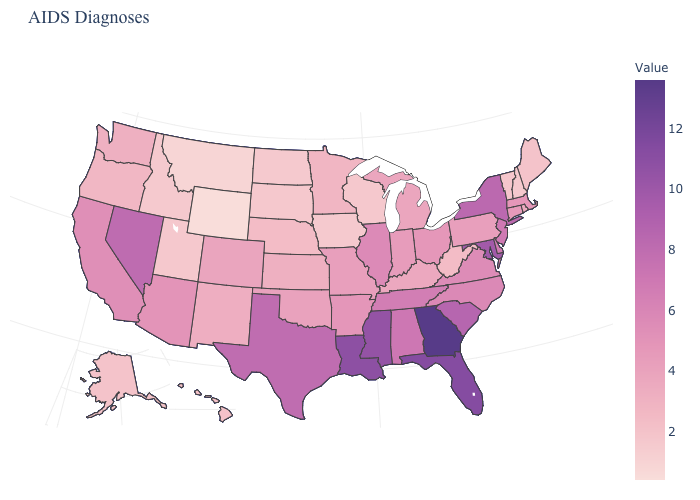Does West Virginia have the lowest value in the South?
Quick response, please. Yes. Among the states that border Oregon , does Washington have the lowest value?
Give a very brief answer. No. Does the map have missing data?
Concise answer only. No. 